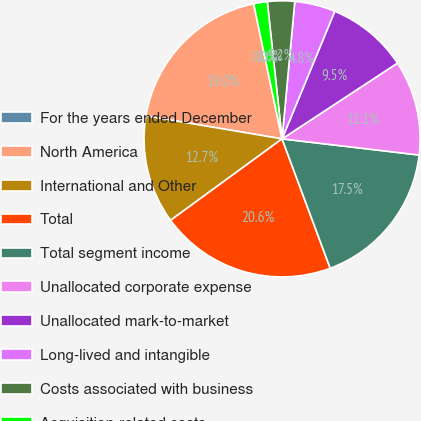Convert chart. <chart><loc_0><loc_0><loc_500><loc_500><pie_chart><fcel>For the years ended December<fcel>North America<fcel>International and Other<fcel>Total<fcel>Total segment income<fcel>Unallocated corporate expense<fcel>Unallocated mark-to-market<fcel>Long-lived and intangible<fcel>Costs associated with business<fcel>Acquisition-related costs<nl><fcel>0.0%<fcel>19.04%<fcel>12.7%<fcel>20.63%<fcel>17.46%<fcel>11.11%<fcel>9.52%<fcel>4.76%<fcel>3.18%<fcel>1.59%<nl></chart> 